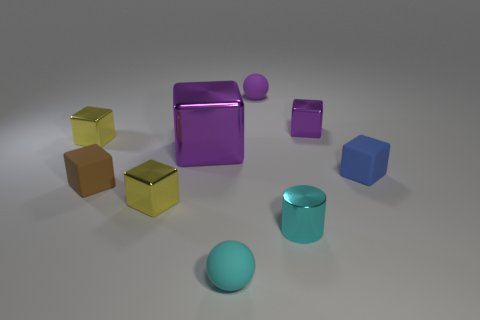What is the size of the brown cube left of the matte ball that is in front of the blue rubber cube?
Your answer should be compact. Small. There is a big metallic cube behind the small brown thing; what color is it?
Offer a terse response. Purple. There is a blue block that is the same material as the small cyan ball; what is its size?
Your response must be concise. Small. How many tiny blue things are the same shape as the tiny cyan metallic object?
Give a very brief answer. 0. What is the material of the other sphere that is the same size as the purple rubber ball?
Keep it short and to the point. Rubber. Is there a green object that has the same material as the small cyan cylinder?
Offer a very short reply. No. The tiny matte thing that is both to the left of the small blue matte object and behind the brown thing is what color?
Ensure brevity in your answer.  Purple. What number of other objects are the same color as the large metal object?
Your answer should be compact. 2. The ball that is in front of the small yellow metal block in front of the yellow thing that is behind the small blue rubber object is made of what material?
Provide a succinct answer. Rubber. How many cubes are either big purple things or tiny blue rubber things?
Ensure brevity in your answer.  2. 